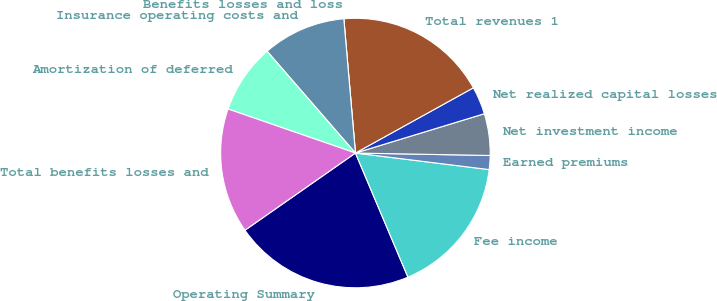Convert chart to OTSL. <chart><loc_0><loc_0><loc_500><loc_500><pie_chart><fcel>Operating Summary<fcel>Fee income<fcel>Earned premiums<fcel>Net investment income<fcel>Net realized capital losses<fcel>Total revenues 1<fcel>Benefits losses and loss<fcel>Insurance operating costs and<fcel>Amortization of deferred<fcel>Total benefits losses and<nl><fcel>21.66%<fcel>16.67%<fcel>1.67%<fcel>5.0%<fcel>3.33%<fcel>18.33%<fcel>0.0%<fcel>10.0%<fcel>8.33%<fcel>15.0%<nl></chart> 